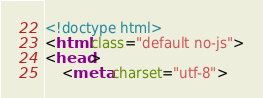<code> <loc_0><loc_0><loc_500><loc_500><_HTML_><!doctype html>
<html class="default no-js">
<head>
	<meta charset="utf-8"></code> 